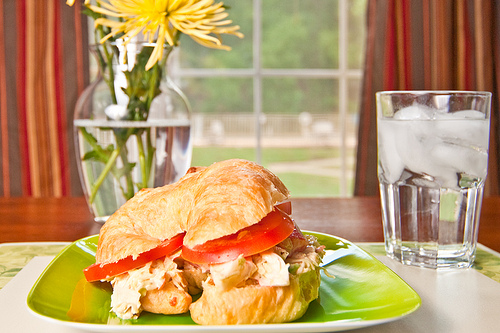Do you see any cheese? No, there is no visible cheese in the image. 